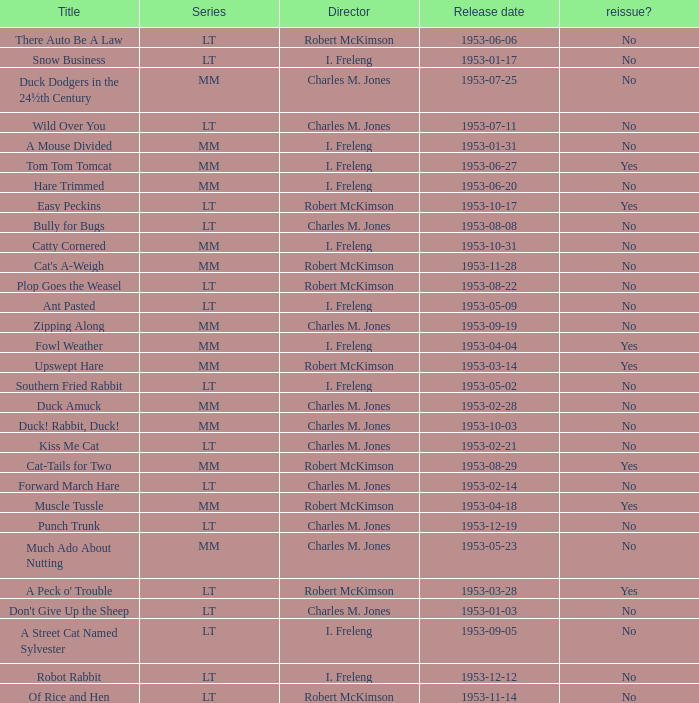What's the title for the release date of 1953-01-31 in the MM series, no reissue, and a director of I. Freleng? A Mouse Divided. 